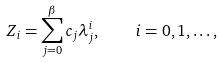Convert formula to latex. <formula><loc_0><loc_0><loc_500><loc_500>Z _ { i } = \sum _ { j = 0 } ^ { \beta } c _ { j } \lambda _ { j } ^ { i } , \quad i = 0 , 1 , \dots ,</formula> 